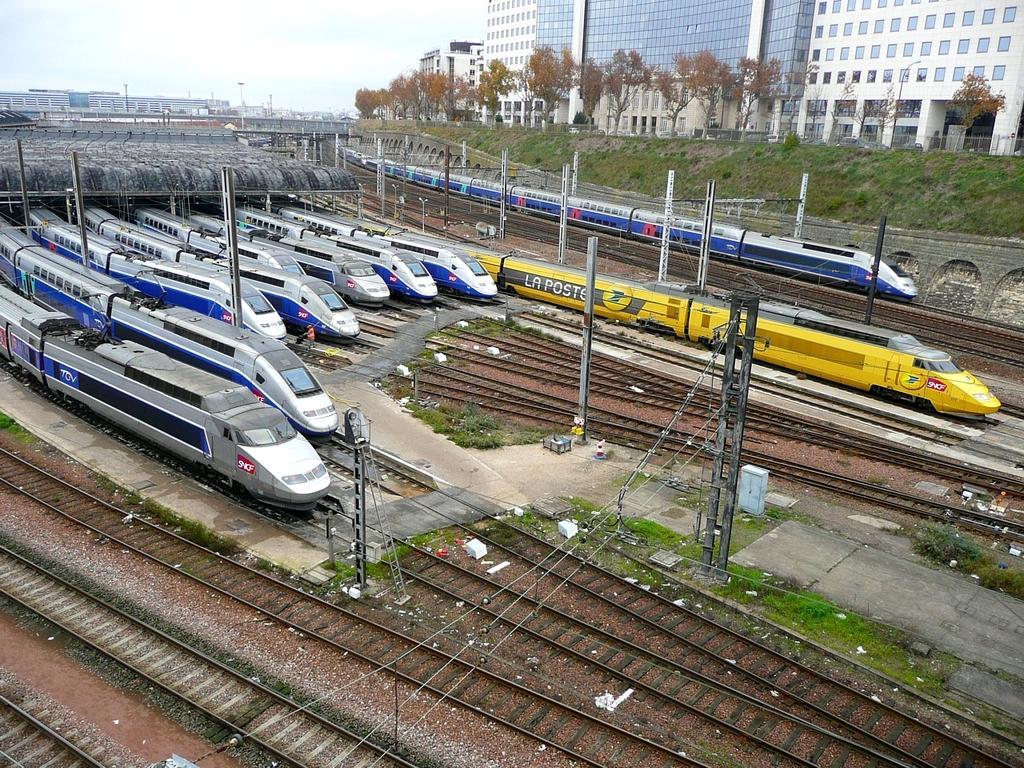Describe this image in one or two sentences. In the image we can see there are trains standing on the railway tracks and there are trees. Behind there are buildings. 